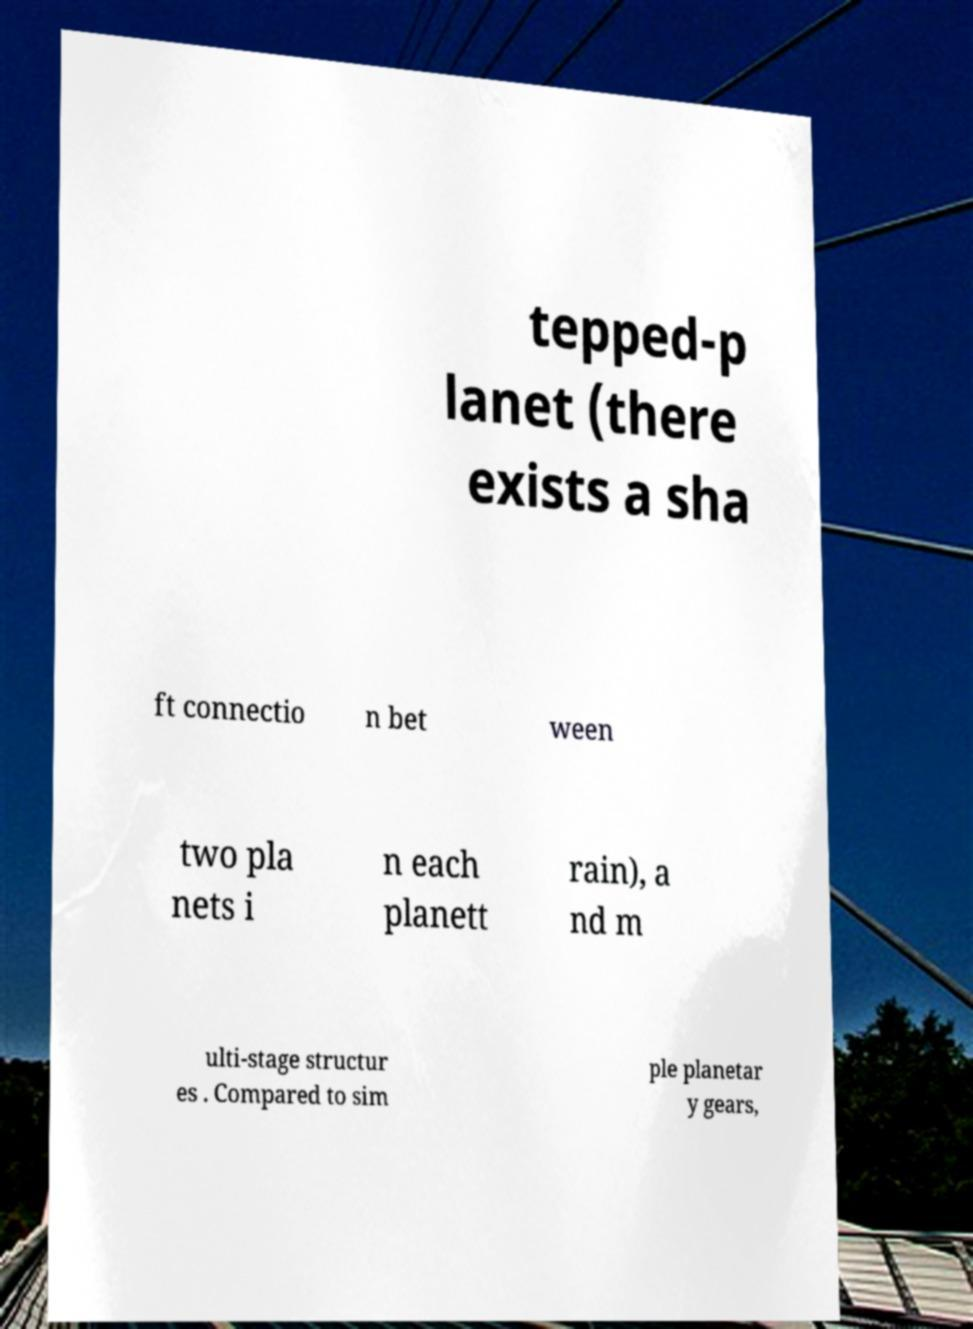Can you read and provide the text displayed in the image?This photo seems to have some interesting text. Can you extract and type it out for me? tepped-p lanet (there exists a sha ft connectio n bet ween two pla nets i n each planett rain), a nd m ulti-stage structur es . Compared to sim ple planetar y gears, 